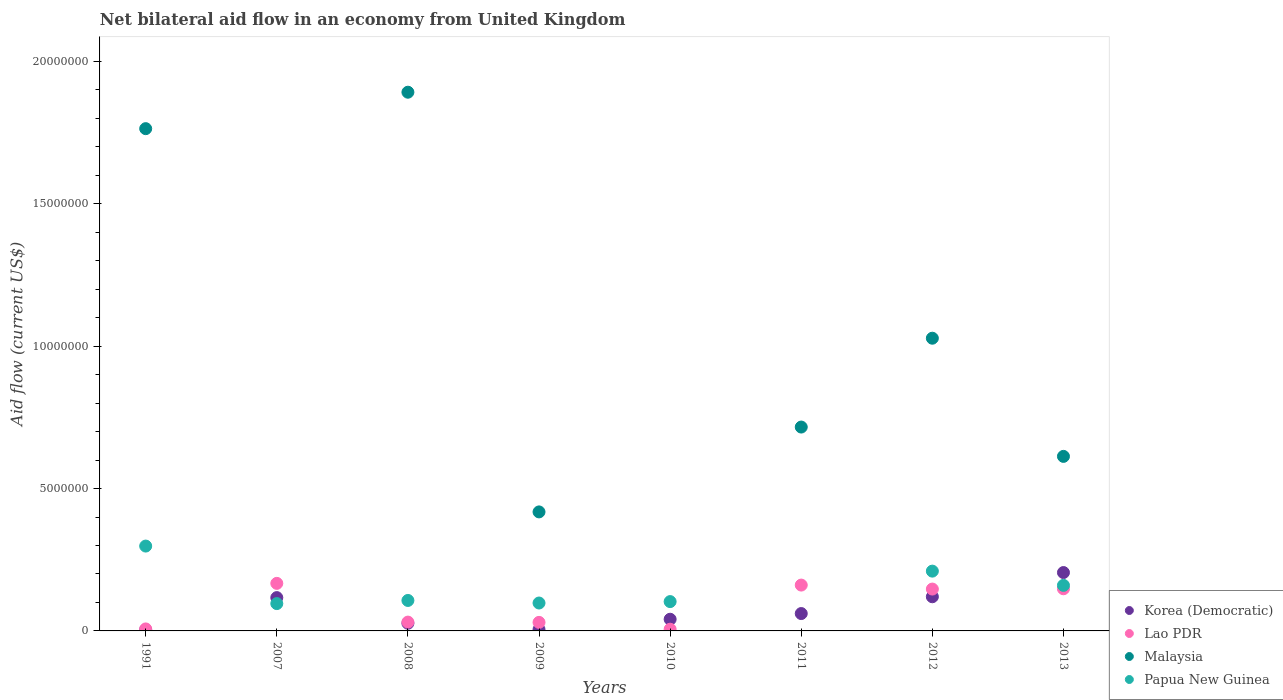How many different coloured dotlines are there?
Ensure brevity in your answer.  4. Is the number of dotlines equal to the number of legend labels?
Ensure brevity in your answer.  No. What is the net bilateral aid flow in Papua New Guinea in 2012?
Offer a terse response. 2.10e+06. Across all years, what is the maximum net bilateral aid flow in Papua New Guinea?
Offer a very short reply. 2.98e+06. Across all years, what is the minimum net bilateral aid flow in Lao PDR?
Provide a succinct answer. 6.00e+04. What is the total net bilateral aid flow in Korea (Democratic) in the graph?
Make the answer very short. 5.80e+06. What is the difference between the net bilateral aid flow in Lao PDR in 2007 and that in 2010?
Keep it short and to the point. 1.61e+06. What is the difference between the net bilateral aid flow in Papua New Guinea in 2008 and the net bilateral aid flow in Lao PDR in 2007?
Your answer should be compact. -6.00e+05. What is the average net bilateral aid flow in Malaysia per year?
Make the answer very short. 8.04e+06. What is the ratio of the net bilateral aid flow in Lao PDR in 2009 to that in 2011?
Provide a short and direct response. 0.19. Is the difference between the net bilateral aid flow in Lao PDR in 1991 and 2008 greater than the difference between the net bilateral aid flow in Korea (Democratic) in 1991 and 2008?
Your answer should be compact. No. What is the difference between the highest and the second highest net bilateral aid flow in Korea (Democratic)?
Keep it short and to the point. 8.50e+05. What is the difference between the highest and the lowest net bilateral aid flow in Papua New Guinea?
Your response must be concise. 2.98e+06. In how many years, is the net bilateral aid flow in Papua New Guinea greater than the average net bilateral aid flow in Papua New Guinea taken over all years?
Ensure brevity in your answer.  3. Does the net bilateral aid flow in Malaysia monotonically increase over the years?
Keep it short and to the point. No. Is the net bilateral aid flow in Korea (Democratic) strictly greater than the net bilateral aid flow in Papua New Guinea over the years?
Keep it short and to the point. No. What is the difference between two consecutive major ticks on the Y-axis?
Provide a short and direct response. 5.00e+06. Does the graph contain any zero values?
Provide a succinct answer. Yes. Does the graph contain grids?
Make the answer very short. No. Where does the legend appear in the graph?
Your response must be concise. Bottom right. How many legend labels are there?
Your answer should be very brief. 4. How are the legend labels stacked?
Ensure brevity in your answer.  Vertical. What is the title of the graph?
Your answer should be compact. Net bilateral aid flow in an economy from United Kingdom. What is the Aid flow (current US$) of Korea (Democratic) in 1991?
Provide a short and direct response. 4.00e+04. What is the Aid flow (current US$) of Lao PDR in 1991?
Your answer should be very brief. 7.00e+04. What is the Aid flow (current US$) in Malaysia in 1991?
Your answer should be very brief. 1.76e+07. What is the Aid flow (current US$) of Papua New Guinea in 1991?
Make the answer very short. 2.98e+06. What is the Aid flow (current US$) in Korea (Democratic) in 2007?
Make the answer very short. 1.17e+06. What is the Aid flow (current US$) in Lao PDR in 2007?
Offer a terse response. 1.67e+06. What is the Aid flow (current US$) in Malaysia in 2007?
Offer a very short reply. 0. What is the Aid flow (current US$) of Papua New Guinea in 2007?
Keep it short and to the point. 9.60e+05. What is the Aid flow (current US$) in Malaysia in 2008?
Offer a terse response. 1.89e+07. What is the Aid flow (current US$) of Papua New Guinea in 2008?
Make the answer very short. 1.07e+06. What is the Aid flow (current US$) of Lao PDR in 2009?
Keep it short and to the point. 3.00e+05. What is the Aid flow (current US$) in Malaysia in 2009?
Give a very brief answer. 4.18e+06. What is the Aid flow (current US$) in Papua New Guinea in 2009?
Keep it short and to the point. 9.80e+05. What is the Aid flow (current US$) in Korea (Democratic) in 2010?
Your answer should be very brief. 4.10e+05. What is the Aid flow (current US$) in Malaysia in 2010?
Offer a very short reply. 0. What is the Aid flow (current US$) of Papua New Guinea in 2010?
Your response must be concise. 1.03e+06. What is the Aid flow (current US$) of Korea (Democratic) in 2011?
Offer a very short reply. 6.10e+05. What is the Aid flow (current US$) of Lao PDR in 2011?
Your answer should be very brief. 1.61e+06. What is the Aid flow (current US$) in Malaysia in 2011?
Your answer should be compact. 7.16e+06. What is the Aid flow (current US$) in Korea (Democratic) in 2012?
Keep it short and to the point. 1.20e+06. What is the Aid flow (current US$) in Lao PDR in 2012?
Provide a succinct answer. 1.47e+06. What is the Aid flow (current US$) of Malaysia in 2012?
Keep it short and to the point. 1.03e+07. What is the Aid flow (current US$) of Papua New Guinea in 2012?
Make the answer very short. 2.10e+06. What is the Aid flow (current US$) in Korea (Democratic) in 2013?
Give a very brief answer. 2.05e+06. What is the Aid flow (current US$) of Lao PDR in 2013?
Make the answer very short. 1.48e+06. What is the Aid flow (current US$) of Malaysia in 2013?
Ensure brevity in your answer.  6.13e+06. What is the Aid flow (current US$) in Papua New Guinea in 2013?
Offer a very short reply. 1.60e+06. Across all years, what is the maximum Aid flow (current US$) in Korea (Democratic)?
Give a very brief answer. 2.05e+06. Across all years, what is the maximum Aid flow (current US$) of Lao PDR?
Your answer should be compact. 1.67e+06. Across all years, what is the maximum Aid flow (current US$) of Malaysia?
Your answer should be compact. 1.89e+07. Across all years, what is the maximum Aid flow (current US$) of Papua New Guinea?
Your answer should be compact. 2.98e+06. Across all years, what is the minimum Aid flow (current US$) in Korea (Democratic)?
Provide a succinct answer. 4.00e+04. Across all years, what is the minimum Aid flow (current US$) of Lao PDR?
Offer a terse response. 6.00e+04. Across all years, what is the minimum Aid flow (current US$) in Papua New Guinea?
Provide a succinct answer. 0. What is the total Aid flow (current US$) in Korea (Democratic) in the graph?
Offer a very short reply. 5.80e+06. What is the total Aid flow (current US$) of Lao PDR in the graph?
Offer a terse response. 6.97e+06. What is the total Aid flow (current US$) of Malaysia in the graph?
Offer a very short reply. 6.43e+07. What is the total Aid flow (current US$) of Papua New Guinea in the graph?
Your answer should be very brief. 1.07e+07. What is the difference between the Aid flow (current US$) in Korea (Democratic) in 1991 and that in 2007?
Provide a succinct answer. -1.13e+06. What is the difference between the Aid flow (current US$) in Lao PDR in 1991 and that in 2007?
Your answer should be compact. -1.60e+06. What is the difference between the Aid flow (current US$) in Papua New Guinea in 1991 and that in 2007?
Give a very brief answer. 2.02e+06. What is the difference between the Aid flow (current US$) in Malaysia in 1991 and that in 2008?
Your response must be concise. -1.28e+06. What is the difference between the Aid flow (current US$) in Papua New Guinea in 1991 and that in 2008?
Make the answer very short. 1.91e+06. What is the difference between the Aid flow (current US$) in Malaysia in 1991 and that in 2009?
Offer a very short reply. 1.35e+07. What is the difference between the Aid flow (current US$) in Korea (Democratic) in 1991 and that in 2010?
Offer a terse response. -3.70e+05. What is the difference between the Aid flow (current US$) in Lao PDR in 1991 and that in 2010?
Keep it short and to the point. 10000. What is the difference between the Aid flow (current US$) in Papua New Guinea in 1991 and that in 2010?
Your answer should be very brief. 1.95e+06. What is the difference between the Aid flow (current US$) in Korea (Democratic) in 1991 and that in 2011?
Provide a succinct answer. -5.70e+05. What is the difference between the Aid flow (current US$) of Lao PDR in 1991 and that in 2011?
Ensure brevity in your answer.  -1.54e+06. What is the difference between the Aid flow (current US$) in Malaysia in 1991 and that in 2011?
Keep it short and to the point. 1.05e+07. What is the difference between the Aid flow (current US$) of Korea (Democratic) in 1991 and that in 2012?
Make the answer very short. -1.16e+06. What is the difference between the Aid flow (current US$) in Lao PDR in 1991 and that in 2012?
Ensure brevity in your answer.  -1.40e+06. What is the difference between the Aid flow (current US$) in Malaysia in 1991 and that in 2012?
Make the answer very short. 7.36e+06. What is the difference between the Aid flow (current US$) of Papua New Guinea in 1991 and that in 2012?
Ensure brevity in your answer.  8.80e+05. What is the difference between the Aid flow (current US$) in Korea (Democratic) in 1991 and that in 2013?
Offer a terse response. -2.01e+06. What is the difference between the Aid flow (current US$) of Lao PDR in 1991 and that in 2013?
Ensure brevity in your answer.  -1.41e+06. What is the difference between the Aid flow (current US$) in Malaysia in 1991 and that in 2013?
Offer a very short reply. 1.15e+07. What is the difference between the Aid flow (current US$) in Papua New Guinea in 1991 and that in 2013?
Provide a succinct answer. 1.38e+06. What is the difference between the Aid flow (current US$) of Lao PDR in 2007 and that in 2008?
Provide a succinct answer. 1.36e+06. What is the difference between the Aid flow (current US$) of Papua New Guinea in 2007 and that in 2008?
Give a very brief answer. -1.10e+05. What is the difference between the Aid flow (current US$) of Korea (Democratic) in 2007 and that in 2009?
Provide a succinct answer. 1.12e+06. What is the difference between the Aid flow (current US$) in Lao PDR in 2007 and that in 2009?
Give a very brief answer. 1.37e+06. What is the difference between the Aid flow (current US$) of Korea (Democratic) in 2007 and that in 2010?
Give a very brief answer. 7.60e+05. What is the difference between the Aid flow (current US$) of Lao PDR in 2007 and that in 2010?
Your answer should be compact. 1.61e+06. What is the difference between the Aid flow (current US$) in Korea (Democratic) in 2007 and that in 2011?
Offer a terse response. 5.60e+05. What is the difference between the Aid flow (current US$) of Lao PDR in 2007 and that in 2011?
Offer a terse response. 6.00e+04. What is the difference between the Aid flow (current US$) of Papua New Guinea in 2007 and that in 2012?
Provide a succinct answer. -1.14e+06. What is the difference between the Aid flow (current US$) of Korea (Democratic) in 2007 and that in 2013?
Keep it short and to the point. -8.80e+05. What is the difference between the Aid flow (current US$) of Lao PDR in 2007 and that in 2013?
Ensure brevity in your answer.  1.90e+05. What is the difference between the Aid flow (current US$) in Papua New Guinea in 2007 and that in 2013?
Keep it short and to the point. -6.40e+05. What is the difference between the Aid flow (current US$) in Korea (Democratic) in 2008 and that in 2009?
Your answer should be compact. 2.20e+05. What is the difference between the Aid flow (current US$) in Malaysia in 2008 and that in 2009?
Give a very brief answer. 1.47e+07. What is the difference between the Aid flow (current US$) in Korea (Democratic) in 2008 and that in 2010?
Keep it short and to the point. -1.40e+05. What is the difference between the Aid flow (current US$) of Lao PDR in 2008 and that in 2010?
Provide a short and direct response. 2.50e+05. What is the difference between the Aid flow (current US$) of Lao PDR in 2008 and that in 2011?
Provide a succinct answer. -1.30e+06. What is the difference between the Aid flow (current US$) of Malaysia in 2008 and that in 2011?
Offer a very short reply. 1.18e+07. What is the difference between the Aid flow (current US$) in Korea (Democratic) in 2008 and that in 2012?
Offer a very short reply. -9.30e+05. What is the difference between the Aid flow (current US$) of Lao PDR in 2008 and that in 2012?
Provide a succinct answer. -1.16e+06. What is the difference between the Aid flow (current US$) of Malaysia in 2008 and that in 2012?
Your response must be concise. 8.64e+06. What is the difference between the Aid flow (current US$) of Papua New Guinea in 2008 and that in 2012?
Your answer should be compact. -1.03e+06. What is the difference between the Aid flow (current US$) in Korea (Democratic) in 2008 and that in 2013?
Provide a short and direct response. -1.78e+06. What is the difference between the Aid flow (current US$) in Lao PDR in 2008 and that in 2013?
Provide a short and direct response. -1.17e+06. What is the difference between the Aid flow (current US$) in Malaysia in 2008 and that in 2013?
Ensure brevity in your answer.  1.28e+07. What is the difference between the Aid flow (current US$) of Papua New Guinea in 2008 and that in 2013?
Give a very brief answer. -5.30e+05. What is the difference between the Aid flow (current US$) of Korea (Democratic) in 2009 and that in 2010?
Your response must be concise. -3.60e+05. What is the difference between the Aid flow (current US$) in Korea (Democratic) in 2009 and that in 2011?
Offer a very short reply. -5.60e+05. What is the difference between the Aid flow (current US$) in Lao PDR in 2009 and that in 2011?
Provide a succinct answer. -1.31e+06. What is the difference between the Aid flow (current US$) of Malaysia in 2009 and that in 2011?
Your response must be concise. -2.98e+06. What is the difference between the Aid flow (current US$) of Korea (Democratic) in 2009 and that in 2012?
Your answer should be very brief. -1.15e+06. What is the difference between the Aid flow (current US$) in Lao PDR in 2009 and that in 2012?
Keep it short and to the point. -1.17e+06. What is the difference between the Aid flow (current US$) in Malaysia in 2009 and that in 2012?
Provide a short and direct response. -6.10e+06. What is the difference between the Aid flow (current US$) in Papua New Guinea in 2009 and that in 2012?
Offer a very short reply. -1.12e+06. What is the difference between the Aid flow (current US$) in Korea (Democratic) in 2009 and that in 2013?
Offer a terse response. -2.00e+06. What is the difference between the Aid flow (current US$) in Lao PDR in 2009 and that in 2013?
Ensure brevity in your answer.  -1.18e+06. What is the difference between the Aid flow (current US$) of Malaysia in 2009 and that in 2013?
Make the answer very short. -1.95e+06. What is the difference between the Aid flow (current US$) in Papua New Guinea in 2009 and that in 2013?
Make the answer very short. -6.20e+05. What is the difference between the Aid flow (current US$) of Korea (Democratic) in 2010 and that in 2011?
Provide a short and direct response. -2.00e+05. What is the difference between the Aid flow (current US$) in Lao PDR in 2010 and that in 2011?
Provide a short and direct response. -1.55e+06. What is the difference between the Aid flow (current US$) of Korea (Democratic) in 2010 and that in 2012?
Make the answer very short. -7.90e+05. What is the difference between the Aid flow (current US$) in Lao PDR in 2010 and that in 2012?
Keep it short and to the point. -1.41e+06. What is the difference between the Aid flow (current US$) in Papua New Guinea in 2010 and that in 2012?
Give a very brief answer. -1.07e+06. What is the difference between the Aid flow (current US$) in Korea (Democratic) in 2010 and that in 2013?
Ensure brevity in your answer.  -1.64e+06. What is the difference between the Aid flow (current US$) of Lao PDR in 2010 and that in 2013?
Keep it short and to the point. -1.42e+06. What is the difference between the Aid flow (current US$) in Papua New Guinea in 2010 and that in 2013?
Keep it short and to the point. -5.70e+05. What is the difference between the Aid flow (current US$) of Korea (Democratic) in 2011 and that in 2012?
Your answer should be very brief. -5.90e+05. What is the difference between the Aid flow (current US$) of Malaysia in 2011 and that in 2012?
Provide a succinct answer. -3.12e+06. What is the difference between the Aid flow (current US$) in Korea (Democratic) in 2011 and that in 2013?
Your response must be concise. -1.44e+06. What is the difference between the Aid flow (current US$) of Malaysia in 2011 and that in 2013?
Ensure brevity in your answer.  1.03e+06. What is the difference between the Aid flow (current US$) of Korea (Democratic) in 2012 and that in 2013?
Your answer should be compact. -8.50e+05. What is the difference between the Aid flow (current US$) in Lao PDR in 2012 and that in 2013?
Make the answer very short. -10000. What is the difference between the Aid flow (current US$) in Malaysia in 2012 and that in 2013?
Offer a terse response. 4.15e+06. What is the difference between the Aid flow (current US$) of Korea (Democratic) in 1991 and the Aid flow (current US$) of Lao PDR in 2007?
Offer a very short reply. -1.63e+06. What is the difference between the Aid flow (current US$) in Korea (Democratic) in 1991 and the Aid flow (current US$) in Papua New Guinea in 2007?
Your answer should be very brief. -9.20e+05. What is the difference between the Aid flow (current US$) in Lao PDR in 1991 and the Aid flow (current US$) in Papua New Guinea in 2007?
Provide a succinct answer. -8.90e+05. What is the difference between the Aid flow (current US$) in Malaysia in 1991 and the Aid flow (current US$) in Papua New Guinea in 2007?
Make the answer very short. 1.67e+07. What is the difference between the Aid flow (current US$) of Korea (Democratic) in 1991 and the Aid flow (current US$) of Malaysia in 2008?
Ensure brevity in your answer.  -1.89e+07. What is the difference between the Aid flow (current US$) in Korea (Democratic) in 1991 and the Aid flow (current US$) in Papua New Guinea in 2008?
Offer a very short reply. -1.03e+06. What is the difference between the Aid flow (current US$) of Lao PDR in 1991 and the Aid flow (current US$) of Malaysia in 2008?
Provide a short and direct response. -1.88e+07. What is the difference between the Aid flow (current US$) in Lao PDR in 1991 and the Aid flow (current US$) in Papua New Guinea in 2008?
Your answer should be very brief. -1.00e+06. What is the difference between the Aid flow (current US$) in Malaysia in 1991 and the Aid flow (current US$) in Papua New Guinea in 2008?
Your answer should be very brief. 1.66e+07. What is the difference between the Aid flow (current US$) in Korea (Democratic) in 1991 and the Aid flow (current US$) in Lao PDR in 2009?
Ensure brevity in your answer.  -2.60e+05. What is the difference between the Aid flow (current US$) in Korea (Democratic) in 1991 and the Aid flow (current US$) in Malaysia in 2009?
Your answer should be very brief. -4.14e+06. What is the difference between the Aid flow (current US$) in Korea (Democratic) in 1991 and the Aid flow (current US$) in Papua New Guinea in 2009?
Provide a short and direct response. -9.40e+05. What is the difference between the Aid flow (current US$) in Lao PDR in 1991 and the Aid flow (current US$) in Malaysia in 2009?
Make the answer very short. -4.11e+06. What is the difference between the Aid flow (current US$) of Lao PDR in 1991 and the Aid flow (current US$) of Papua New Guinea in 2009?
Your answer should be very brief. -9.10e+05. What is the difference between the Aid flow (current US$) in Malaysia in 1991 and the Aid flow (current US$) in Papua New Guinea in 2009?
Ensure brevity in your answer.  1.67e+07. What is the difference between the Aid flow (current US$) of Korea (Democratic) in 1991 and the Aid flow (current US$) of Papua New Guinea in 2010?
Provide a short and direct response. -9.90e+05. What is the difference between the Aid flow (current US$) in Lao PDR in 1991 and the Aid flow (current US$) in Papua New Guinea in 2010?
Ensure brevity in your answer.  -9.60e+05. What is the difference between the Aid flow (current US$) of Malaysia in 1991 and the Aid flow (current US$) of Papua New Guinea in 2010?
Provide a succinct answer. 1.66e+07. What is the difference between the Aid flow (current US$) of Korea (Democratic) in 1991 and the Aid flow (current US$) of Lao PDR in 2011?
Offer a terse response. -1.57e+06. What is the difference between the Aid flow (current US$) in Korea (Democratic) in 1991 and the Aid flow (current US$) in Malaysia in 2011?
Offer a very short reply. -7.12e+06. What is the difference between the Aid flow (current US$) in Lao PDR in 1991 and the Aid flow (current US$) in Malaysia in 2011?
Provide a short and direct response. -7.09e+06. What is the difference between the Aid flow (current US$) of Korea (Democratic) in 1991 and the Aid flow (current US$) of Lao PDR in 2012?
Provide a short and direct response. -1.43e+06. What is the difference between the Aid flow (current US$) of Korea (Democratic) in 1991 and the Aid flow (current US$) of Malaysia in 2012?
Provide a succinct answer. -1.02e+07. What is the difference between the Aid flow (current US$) in Korea (Democratic) in 1991 and the Aid flow (current US$) in Papua New Guinea in 2012?
Ensure brevity in your answer.  -2.06e+06. What is the difference between the Aid flow (current US$) in Lao PDR in 1991 and the Aid flow (current US$) in Malaysia in 2012?
Your answer should be very brief. -1.02e+07. What is the difference between the Aid flow (current US$) of Lao PDR in 1991 and the Aid flow (current US$) of Papua New Guinea in 2012?
Provide a succinct answer. -2.03e+06. What is the difference between the Aid flow (current US$) in Malaysia in 1991 and the Aid flow (current US$) in Papua New Guinea in 2012?
Your answer should be very brief. 1.55e+07. What is the difference between the Aid flow (current US$) of Korea (Democratic) in 1991 and the Aid flow (current US$) of Lao PDR in 2013?
Provide a short and direct response. -1.44e+06. What is the difference between the Aid flow (current US$) in Korea (Democratic) in 1991 and the Aid flow (current US$) in Malaysia in 2013?
Give a very brief answer. -6.09e+06. What is the difference between the Aid flow (current US$) of Korea (Democratic) in 1991 and the Aid flow (current US$) of Papua New Guinea in 2013?
Provide a short and direct response. -1.56e+06. What is the difference between the Aid flow (current US$) of Lao PDR in 1991 and the Aid flow (current US$) of Malaysia in 2013?
Keep it short and to the point. -6.06e+06. What is the difference between the Aid flow (current US$) of Lao PDR in 1991 and the Aid flow (current US$) of Papua New Guinea in 2013?
Give a very brief answer. -1.53e+06. What is the difference between the Aid flow (current US$) of Malaysia in 1991 and the Aid flow (current US$) of Papua New Guinea in 2013?
Offer a terse response. 1.60e+07. What is the difference between the Aid flow (current US$) in Korea (Democratic) in 2007 and the Aid flow (current US$) in Lao PDR in 2008?
Give a very brief answer. 8.60e+05. What is the difference between the Aid flow (current US$) of Korea (Democratic) in 2007 and the Aid flow (current US$) of Malaysia in 2008?
Provide a succinct answer. -1.78e+07. What is the difference between the Aid flow (current US$) of Korea (Democratic) in 2007 and the Aid flow (current US$) of Papua New Guinea in 2008?
Provide a short and direct response. 1.00e+05. What is the difference between the Aid flow (current US$) of Lao PDR in 2007 and the Aid flow (current US$) of Malaysia in 2008?
Ensure brevity in your answer.  -1.72e+07. What is the difference between the Aid flow (current US$) in Lao PDR in 2007 and the Aid flow (current US$) in Papua New Guinea in 2008?
Your response must be concise. 6.00e+05. What is the difference between the Aid flow (current US$) of Korea (Democratic) in 2007 and the Aid flow (current US$) of Lao PDR in 2009?
Offer a very short reply. 8.70e+05. What is the difference between the Aid flow (current US$) of Korea (Democratic) in 2007 and the Aid flow (current US$) of Malaysia in 2009?
Provide a short and direct response. -3.01e+06. What is the difference between the Aid flow (current US$) in Korea (Democratic) in 2007 and the Aid flow (current US$) in Papua New Guinea in 2009?
Provide a succinct answer. 1.90e+05. What is the difference between the Aid flow (current US$) in Lao PDR in 2007 and the Aid flow (current US$) in Malaysia in 2009?
Your answer should be compact. -2.51e+06. What is the difference between the Aid flow (current US$) in Lao PDR in 2007 and the Aid flow (current US$) in Papua New Guinea in 2009?
Offer a very short reply. 6.90e+05. What is the difference between the Aid flow (current US$) in Korea (Democratic) in 2007 and the Aid flow (current US$) in Lao PDR in 2010?
Offer a terse response. 1.11e+06. What is the difference between the Aid flow (current US$) of Lao PDR in 2007 and the Aid flow (current US$) of Papua New Guinea in 2010?
Make the answer very short. 6.40e+05. What is the difference between the Aid flow (current US$) of Korea (Democratic) in 2007 and the Aid flow (current US$) of Lao PDR in 2011?
Your answer should be very brief. -4.40e+05. What is the difference between the Aid flow (current US$) of Korea (Democratic) in 2007 and the Aid flow (current US$) of Malaysia in 2011?
Provide a short and direct response. -5.99e+06. What is the difference between the Aid flow (current US$) in Lao PDR in 2007 and the Aid flow (current US$) in Malaysia in 2011?
Your answer should be compact. -5.49e+06. What is the difference between the Aid flow (current US$) in Korea (Democratic) in 2007 and the Aid flow (current US$) in Lao PDR in 2012?
Your answer should be very brief. -3.00e+05. What is the difference between the Aid flow (current US$) of Korea (Democratic) in 2007 and the Aid flow (current US$) of Malaysia in 2012?
Make the answer very short. -9.11e+06. What is the difference between the Aid flow (current US$) of Korea (Democratic) in 2007 and the Aid flow (current US$) of Papua New Guinea in 2012?
Ensure brevity in your answer.  -9.30e+05. What is the difference between the Aid flow (current US$) of Lao PDR in 2007 and the Aid flow (current US$) of Malaysia in 2012?
Your response must be concise. -8.61e+06. What is the difference between the Aid flow (current US$) of Lao PDR in 2007 and the Aid flow (current US$) of Papua New Guinea in 2012?
Offer a very short reply. -4.30e+05. What is the difference between the Aid flow (current US$) of Korea (Democratic) in 2007 and the Aid flow (current US$) of Lao PDR in 2013?
Keep it short and to the point. -3.10e+05. What is the difference between the Aid flow (current US$) in Korea (Democratic) in 2007 and the Aid flow (current US$) in Malaysia in 2013?
Ensure brevity in your answer.  -4.96e+06. What is the difference between the Aid flow (current US$) of Korea (Democratic) in 2007 and the Aid flow (current US$) of Papua New Guinea in 2013?
Keep it short and to the point. -4.30e+05. What is the difference between the Aid flow (current US$) in Lao PDR in 2007 and the Aid flow (current US$) in Malaysia in 2013?
Make the answer very short. -4.46e+06. What is the difference between the Aid flow (current US$) in Lao PDR in 2007 and the Aid flow (current US$) in Papua New Guinea in 2013?
Your response must be concise. 7.00e+04. What is the difference between the Aid flow (current US$) in Korea (Democratic) in 2008 and the Aid flow (current US$) in Malaysia in 2009?
Offer a terse response. -3.91e+06. What is the difference between the Aid flow (current US$) in Korea (Democratic) in 2008 and the Aid flow (current US$) in Papua New Guinea in 2009?
Give a very brief answer. -7.10e+05. What is the difference between the Aid flow (current US$) in Lao PDR in 2008 and the Aid flow (current US$) in Malaysia in 2009?
Offer a very short reply. -3.87e+06. What is the difference between the Aid flow (current US$) of Lao PDR in 2008 and the Aid flow (current US$) of Papua New Guinea in 2009?
Ensure brevity in your answer.  -6.70e+05. What is the difference between the Aid flow (current US$) in Malaysia in 2008 and the Aid flow (current US$) in Papua New Guinea in 2009?
Give a very brief answer. 1.79e+07. What is the difference between the Aid flow (current US$) of Korea (Democratic) in 2008 and the Aid flow (current US$) of Lao PDR in 2010?
Make the answer very short. 2.10e+05. What is the difference between the Aid flow (current US$) in Korea (Democratic) in 2008 and the Aid flow (current US$) in Papua New Guinea in 2010?
Your answer should be compact. -7.60e+05. What is the difference between the Aid flow (current US$) of Lao PDR in 2008 and the Aid flow (current US$) of Papua New Guinea in 2010?
Keep it short and to the point. -7.20e+05. What is the difference between the Aid flow (current US$) of Malaysia in 2008 and the Aid flow (current US$) of Papua New Guinea in 2010?
Give a very brief answer. 1.79e+07. What is the difference between the Aid flow (current US$) of Korea (Democratic) in 2008 and the Aid flow (current US$) of Lao PDR in 2011?
Offer a terse response. -1.34e+06. What is the difference between the Aid flow (current US$) in Korea (Democratic) in 2008 and the Aid flow (current US$) in Malaysia in 2011?
Make the answer very short. -6.89e+06. What is the difference between the Aid flow (current US$) in Lao PDR in 2008 and the Aid flow (current US$) in Malaysia in 2011?
Your answer should be very brief. -6.85e+06. What is the difference between the Aid flow (current US$) in Korea (Democratic) in 2008 and the Aid flow (current US$) in Lao PDR in 2012?
Offer a very short reply. -1.20e+06. What is the difference between the Aid flow (current US$) in Korea (Democratic) in 2008 and the Aid flow (current US$) in Malaysia in 2012?
Give a very brief answer. -1.00e+07. What is the difference between the Aid flow (current US$) of Korea (Democratic) in 2008 and the Aid flow (current US$) of Papua New Guinea in 2012?
Offer a very short reply. -1.83e+06. What is the difference between the Aid flow (current US$) in Lao PDR in 2008 and the Aid flow (current US$) in Malaysia in 2012?
Your response must be concise. -9.97e+06. What is the difference between the Aid flow (current US$) in Lao PDR in 2008 and the Aid flow (current US$) in Papua New Guinea in 2012?
Your answer should be compact. -1.79e+06. What is the difference between the Aid flow (current US$) in Malaysia in 2008 and the Aid flow (current US$) in Papua New Guinea in 2012?
Provide a short and direct response. 1.68e+07. What is the difference between the Aid flow (current US$) of Korea (Democratic) in 2008 and the Aid flow (current US$) of Lao PDR in 2013?
Your answer should be compact. -1.21e+06. What is the difference between the Aid flow (current US$) of Korea (Democratic) in 2008 and the Aid flow (current US$) of Malaysia in 2013?
Keep it short and to the point. -5.86e+06. What is the difference between the Aid flow (current US$) in Korea (Democratic) in 2008 and the Aid flow (current US$) in Papua New Guinea in 2013?
Ensure brevity in your answer.  -1.33e+06. What is the difference between the Aid flow (current US$) of Lao PDR in 2008 and the Aid flow (current US$) of Malaysia in 2013?
Provide a short and direct response. -5.82e+06. What is the difference between the Aid flow (current US$) of Lao PDR in 2008 and the Aid flow (current US$) of Papua New Guinea in 2013?
Keep it short and to the point. -1.29e+06. What is the difference between the Aid flow (current US$) in Malaysia in 2008 and the Aid flow (current US$) in Papua New Guinea in 2013?
Your answer should be very brief. 1.73e+07. What is the difference between the Aid flow (current US$) in Korea (Democratic) in 2009 and the Aid flow (current US$) in Papua New Guinea in 2010?
Your answer should be very brief. -9.80e+05. What is the difference between the Aid flow (current US$) of Lao PDR in 2009 and the Aid flow (current US$) of Papua New Guinea in 2010?
Keep it short and to the point. -7.30e+05. What is the difference between the Aid flow (current US$) in Malaysia in 2009 and the Aid flow (current US$) in Papua New Guinea in 2010?
Your response must be concise. 3.15e+06. What is the difference between the Aid flow (current US$) of Korea (Democratic) in 2009 and the Aid flow (current US$) of Lao PDR in 2011?
Make the answer very short. -1.56e+06. What is the difference between the Aid flow (current US$) in Korea (Democratic) in 2009 and the Aid flow (current US$) in Malaysia in 2011?
Keep it short and to the point. -7.11e+06. What is the difference between the Aid flow (current US$) in Lao PDR in 2009 and the Aid flow (current US$) in Malaysia in 2011?
Ensure brevity in your answer.  -6.86e+06. What is the difference between the Aid flow (current US$) in Korea (Democratic) in 2009 and the Aid flow (current US$) in Lao PDR in 2012?
Offer a terse response. -1.42e+06. What is the difference between the Aid flow (current US$) of Korea (Democratic) in 2009 and the Aid flow (current US$) of Malaysia in 2012?
Provide a short and direct response. -1.02e+07. What is the difference between the Aid flow (current US$) in Korea (Democratic) in 2009 and the Aid flow (current US$) in Papua New Guinea in 2012?
Your answer should be very brief. -2.05e+06. What is the difference between the Aid flow (current US$) of Lao PDR in 2009 and the Aid flow (current US$) of Malaysia in 2012?
Offer a very short reply. -9.98e+06. What is the difference between the Aid flow (current US$) of Lao PDR in 2009 and the Aid flow (current US$) of Papua New Guinea in 2012?
Ensure brevity in your answer.  -1.80e+06. What is the difference between the Aid flow (current US$) in Malaysia in 2009 and the Aid flow (current US$) in Papua New Guinea in 2012?
Ensure brevity in your answer.  2.08e+06. What is the difference between the Aid flow (current US$) of Korea (Democratic) in 2009 and the Aid flow (current US$) of Lao PDR in 2013?
Ensure brevity in your answer.  -1.43e+06. What is the difference between the Aid flow (current US$) of Korea (Democratic) in 2009 and the Aid flow (current US$) of Malaysia in 2013?
Offer a terse response. -6.08e+06. What is the difference between the Aid flow (current US$) in Korea (Democratic) in 2009 and the Aid flow (current US$) in Papua New Guinea in 2013?
Provide a short and direct response. -1.55e+06. What is the difference between the Aid flow (current US$) in Lao PDR in 2009 and the Aid flow (current US$) in Malaysia in 2013?
Your answer should be compact. -5.83e+06. What is the difference between the Aid flow (current US$) in Lao PDR in 2009 and the Aid flow (current US$) in Papua New Guinea in 2013?
Your response must be concise. -1.30e+06. What is the difference between the Aid flow (current US$) in Malaysia in 2009 and the Aid flow (current US$) in Papua New Guinea in 2013?
Provide a succinct answer. 2.58e+06. What is the difference between the Aid flow (current US$) in Korea (Democratic) in 2010 and the Aid flow (current US$) in Lao PDR in 2011?
Give a very brief answer. -1.20e+06. What is the difference between the Aid flow (current US$) of Korea (Democratic) in 2010 and the Aid flow (current US$) of Malaysia in 2011?
Keep it short and to the point. -6.75e+06. What is the difference between the Aid flow (current US$) in Lao PDR in 2010 and the Aid flow (current US$) in Malaysia in 2011?
Provide a short and direct response. -7.10e+06. What is the difference between the Aid flow (current US$) in Korea (Democratic) in 2010 and the Aid flow (current US$) in Lao PDR in 2012?
Your response must be concise. -1.06e+06. What is the difference between the Aid flow (current US$) in Korea (Democratic) in 2010 and the Aid flow (current US$) in Malaysia in 2012?
Ensure brevity in your answer.  -9.87e+06. What is the difference between the Aid flow (current US$) in Korea (Democratic) in 2010 and the Aid flow (current US$) in Papua New Guinea in 2012?
Offer a very short reply. -1.69e+06. What is the difference between the Aid flow (current US$) in Lao PDR in 2010 and the Aid flow (current US$) in Malaysia in 2012?
Provide a short and direct response. -1.02e+07. What is the difference between the Aid flow (current US$) of Lao PDR in 2010 and the Aid flow (current US$) of Papua New Guinea in 2012?
Give a very brief answer. -2.04e+06. What is the difference between the Aid flow (current US$) of Korea (Democratic) in 2010 and the Aid flow (current US$) of Lao PDR in 2013?
Offer a terse response. -1.07e+06. What is the difference between the Aid flow (current US$) in Korea (Democratic) in 2010 and the Aid flow (current US$) in Malaysia in 2013?
Provide a short and direct response. -5.72e+06. What is the difference between the Aid flow (current US$) in Korea (Democratic) in 2010 and the Aid flow (current US$) in Papua New Guinea in 2013?
Offer a very short reply. -1.19e+06. What is the difference between the Aid flow (current US$) of Lao PDR in 2010 and the Aid flow (current US$) of Malaysia in 2013?
Offer a very short reply. -6.07e+06. What is the difference between the Aid flow (current US$) of Lao PDR in 2010 and the Aid flow (current US$) of Papua New Guinea in 2013?
Keep it short and to the point. -1.54e+06. What is the difference between the Aid flow (current US$) of Korea (Democratic) in 2011 and the Aid flow (current US$) of Lao PDR in 2012?
Provide a short and direct response. -8.60e+05. What is the difference between the Aid flow (current US$) of Korea (Democratic) in 2011 and the Aid flow (current US$) of Malaysia in 2012?
Your response must be concise. -9.67e+06. What is the difference between the Aid flow (current US$) of Korea (Democratic) in 2011 and the Aid flow (current US$) of Papua New Guinea in 2012?
Your answer should be very brief. -1.49e+06. What is the difference between the Aid flow (current US$) in Lao PDR in 2011 and the Aid flow (current US$) in Malaysia in 2012?
Keep it short and to the point. -8.67e+06. What is the difference between the Aid flow (current US$) of Lao PDR in 2011 and the Aid flow (current US$) of Papua New Guinea in 2012?
Give a very brief answer. -4.90e+05. What is the difference between the Aid flow (current US$) in Malaysia in 2011 and the Aid flow (current US$) in Papua New Guinea in 2012?
Provide a short and direct response. 5.06e+06. What is the difference between the Aid flow (current US$) in Korea (Democratic) in 2011 and the Aid flow (current US$) in Lao PDR in 2013?
Give a very brief answer. -8.70e+05. What is the difference between the Aid flow (current US$) of Korea (Democratic) in 2011 and the Aid flow (current US$) of Malaysia in 2013?
Ensure brevity in your answer.  -5.52e+06. What is the difference between the Aid flow (current US$) in Korea (Democratic) in 2011 and the Aid flow (current US$) in Papua New Guinea in 2013?
Your answer should be very brief. -9.90e+05. What is the difference between the Aid flow (current US$) of Lao PDR in 2011 and the Aid flow (current US$) of Malaysia in 2013?
Provide a short and direct response. -4.52e+06. What is the difference between the Aid flow (current US$) in Lao PDR in 2011 and the Aid flow (current US$) in Papua New Guinea in 2013?
Your answer should be very brief. 10000. What is the difference between the Aid flow (current US$) in Malaysia in 2011 and the Aid flow (current US$) in Papua New Guinea in 2013?
Your answer should be very brief. 5.56e+06. What is the difference between the Aid flow (current US$) in Korea (Democratic) in 2012 and the Aid flow (current US$) in Lao PDR in 2013?
Your response must be concise. -2.80e+05. What is the difference between the Aid flow (current US$) in Korea (Democratic) in 2012 and the Aid flow (current US$) in Malaysia in 2013?
Ensure brevity in your answer.  -4.93e+06. What is the difference between the Aid flow (current US$) of Korea (Democratic) in 2012 and the Aid flow (current US$) of Papua New Guinea in 2013?
Your response must be concise. -4.00e+05. What is the difference between the Aid flow (current US$) in Lao PDR in 2012 and the Aid flow (current US$) in Malaysia in 2013?
Provide a short and direct response. -4.66e+06. What is the difference between the Aid flow (current US$) of Malaysia in 2012 and the Aid flow (current US$) of Papua New Guinea in 2013?
Offer a very short reply. 8.68e+06. What is the average Aid flow (current US$) in Korea (Democratic) per year?
Provide a short and direct response. 7.25e+05. What is the average Aid flow (current US$) in Lao PDR per year?
Provide a succinct answer. 8.71e+05. What is the average Aid flow (current US$) in Malaysia per year?
Keep it short and to the point. 8.04e+06. What is the average Aid flow (current US$) in Papua New Guinea per year?
Your response must be concise. 1.34e+06. In the year 1991, what is the difference between the Aid flow (current US$) of Korea (Democratic) and Aid flow (current US$) of Malaysia?
Your answer should be very brief. -1.76e+07. In the year 1991, what is the difference between the Aid flow (current US$) in Korea (Democratic) and Aid flow (current US$) in Papua New Guinea?
Your response must be concise. -2.94e+06. In the year 1991, what is the difference between the Aid flow (current US$) of Lao PDR and Aid flow (current US$) of Malaysia?
Keep it short and to the point. -1.76e+07. In the year 1991, what is the difference between the Aid flow (current US$) in Lao PDR and Aid flow (current US$) in Papua New Guinea?
Provide a short and direct response. -2.91e+06. In the year 1991, what is the difference between the Aid flow (current US$) of Malaysia and Aid flow (current US$) of Papua New Guinea?
Provide a succinct answer. 1.47e+07. In the year 2007, what is the difference between the Aid flow (current US$) in Korea (Democratic) and Aid flow (current US$) in Lao PDR?
Provide a short and direct response. -5.00e+05. In the year 2007, what is the difference between the Aid flow (current US$) in Korea (Democratic) and Aid flow (current US$) in Papua New Guinea?
Ensure brevity in your answer.  2.10e+05. In the year 2007, what is the difference between the Aid flow (current US$) of Lao PDR and Aid flow (current US$) of Papua New Guinea?
Your response must be concise. 7.10e+05. In the year 2008, what is the difference between the Aid flow (current US$) of Korea (Democratic) and Aid flow (current US$) of Malaysia?
Ensure brevity in your answer.  -1.86e+07. In the year 2008, what is the difference between the Aid flow (current US$) of Korea (Democratic) and Aid flow (current US$) of Papua New Guinea?
Ensure brevity in your answer.  -8.00e+05. In the year 2008, what is the difference between the Aid flow (current US$) in Lao PDR and Aid flow (current US$) in Malaysia?
Offer a terse response. -1.86e+07. In the year 2008, what is the difference between the Aid flow (current US$) in Lao PDR and Aid flow (current US$) in Papua New Guinea?
Offer a very short reply. -7.60e+05. In the year 2008, what is the difference between the Aid flow (current US$) in Malaysia and Aid flow (current US$) in Papua New Guinea?
Your answer should be compact. 1.78e+07. In the year 2009, what is the difference between the Aid flow (current US$) in Korea (Democratic) and Aid flow (current US$) in Malaysia?
Your answer should be very brief. -4.13e+06. In the year 2009, what is the difference between the Aid flow (current US$) in Korea (Democratic) and Aid flow (current US$) in Papua New Guinea?
Give a very brief answer. -9.30e+05. In the year 2009, what is the difference between the Aid flow (current US$) of Lao PDR and Aid flow (current US$) of Malaysia?
Offer a very short reply. -3.88e+06. In the year 2009, what is the difference between the Aid flow (current US$) of Lao PDR and Aid flow (current US$) of Papua New Guinea?
Offer a very short reply. -6.80e+05. In the year 2009, what is the difference between the Aid flow (current US$) of Malaysia and Aid flow (current US$) of Papua New Guinea?
Provide a short and direct response. 3.20e+06. In the year 2010, what is the difference between the Aid flow (current US$) in Korea (Democratic) and Aid flow (current US$) in Papua New Guinea?
Give a very brief answer. -6.20e+05. In the year 2010, what is the difference between the Aid flow (current US$) of Lao PDR and Aid flow (current US$) of Papua New Guinea?
Provide a short and direct response. -9.70e+05. In the year 2011, what is the difference between the Aid flow (current US$) in Korea (Democratic) and Aid flow (current US$) in Malaysia?
Offer a terse response. -6.55e+06. In the year 2011, what is the difference between the Aid flow (current US$) of Lao PDR and Aid flow (current US$) of Malaysia?
Your response must be concise. -5.55e+06. In the year 2012, what is the difference between the Aid flow (current US$) in Korea (Democratic) and Aid flow (current US$) in Lao PDR?
Your answer should be very brief. -2.70e+05. In the year 2012, what is the difference between the Aid flow (current US$) in Korea (Democratic) and Aid flow (current US$) in Malaysia?
Your answer should be compact. -9.08e+06. In the year 2012, what is the difference between the Aid flow (current US$) of Korea (Democratic) and Aid flow (current US$) of Papua New Guinea?
Offer a terse response. -9.00e+05. In the year 2012, what is the difference between the Aid flow (current US$) in Lao PDR and Aid flow (current US$) in Malaysia?
Your response must be concise. -8.81e+06. In the year 2012, what is the difference between the Aid flow (current US$) of Lao PDR and Aid flow (current US$) of Papua New Guinea?
Provide a short and direct response. -6.30e+05. In the year 2012, what is the difference between the Aid flow (current US$) in Malaysia and Aid flow (current US$) in Papua New Guinea?
Offer a very short reply. 8.18e+06. In the year 2013, what is the difference between the Aid flow (current US$) of Korea (Democratic) and Aid flow (current US$) of Lao PDR?
Provide a short and direct response. 5.70e+05. In the year 2013, what is the difference between the Aid flow (current US$) in Korea (Democratic) and Aid flow (current US$) in Malaysia?
Provide a succinct answer. -4.08e+06. In the year 2013, what is the difference between the Aid flow (current US$) of Korea (Democratic) and Aid flow (current US$) of Papua New Guinea?
Make the answer very short. 4.50e+05. In the year 2013, what is the difference between the Aid flow (current US$) in Lao PDR and Aid flow (current US$) in Malaysia?
Your answer should be compact. -4.65e+06. In the year 2013, what is the difference between the Aid flow (current US$) in Malaysia and Aid flow (current US$) in Papua New Guinea?
Ensure brevity in your answer.  4.53e+06. What is the ratio of the Aid flow (current US$) in Korea (Democratic) in 1991 to that in 2007?
Offer a very short reply. 0.03. What is the ratio of the Aid flow (current US$) in Lao PDR in 1991 to that in 2007?
Your answer should be very brief. 0.04. What is the ratio of the Aid flow (current US$) in Papua New Guinea in 1991 to that in 2007?
Give a very brief answer. 3.1. What is the ratio of the Aid flow (current US$) in Korea (Democratic) in 1991 to that in 2008?
Your response must be concise. 0.15. What is the ratio of the Aid flow (current US$) in Lao PDR in 1991 to that in 2008?
Your answer should be very brief. 0.23. What is the ratio of the Aid flow (current US$) of Malaysia in 1991 to that in 2008?
Keep it short and to the point. 0.93. What is the ratio of the Aid flow (current US$) in Papua New Guinea in 1991 to that in 2008?
Your answer should be compact. 2.79. What is the ratio of the Aid flow (current US$) in Lao PDR in 1991 to that in 2009?
Your response must be concise. 0.23. What is the ratio of the Aid flow (current US$) in Malaysia in 1991 to that in 2009?
Provide a short and direct response. 4.22. What is the ratio of the Aid flow (current US$) in Papua New Guinea in 1991 to that in 2009?
Your answer should be very brief. 3.04. What is the ratio of the Aid flow (current US$) in Korea (Democratic) in 1991 to that in 2010?
Offer a very short reply. 0.1. What is the ratio of the Aid flow (current US$) in Lao PDR in 1991 to that in 2010?
Make the answer very short. 1.17. What is the ratio of the Aid flow (current US$) of Papua New Guinea in 1991 to that in 2010?
Your response must be concise. 2.89. What is the ratio of the Aid flow (current US$) of Korea (Democratic) in 1991 to that in 2011?
Ensure brevity in your answer.  0.07. What is the ratio of the Aid flow (current US$) in Lao PDR in 1991 to that in 2011?
Keep it short and to the point. 0.04. What is the ratio of the Aid flow (current US$) in Malaysia in 1991 to that in 2011?
Offer a terse response. 2.46. What is the ratio of the Aid flow (current US$) in Lao PDR in 1991 to that in 2012?
Give a very brief answer. 0.05. What is the ratio of the Aid flow (current US$) of Malaysia in 1991 to that in 2012?
Provide a succinct answer. 1.72. What is the ratio of the Aid flow (current US$) of Papua New Guinea in 1991 to that in 2012?
Your answer should be very brief. 1.42. What is the ratio of the Aid flow (current US$) of Korea (Democratic) in 1991 to that in 2013?
Provide a short and direct response. 0.02. What is the ratio of the Aid flow (current US$) of Lao PDR in 1991 to that in 2013?
Offer a terse response. 0.05. What is the ratio of the Aid flow (current US$) of Malaysia in 1991 to that in 2013?
Your answer should be very brief. 2.88. What is the ratio of the Aid flow (current US$) of Papua New Guinea in 1991 to that in 2013?
Your answer should be very brief. 1.86. What is the ratio of the Aid flow (current US$) of Korea (Democratic) in 2007 to that in 2008?
Offer a terse response. 4.33. What is the ratio of the Aid flow (current US$) in Lao PDR in 2007 to that in 2008?
Offer a very short reply. 5.39. What is the ratio of the Aid flow (current US$) in Papua New Guinea in 2007 to that in 2008?
Give a very brief answer. 0.9. What is the ratio of the Aid flow (current US$) of Korea (Democratic) in 2007 to that in 2009?
Give a very brief answer. 23.4. What is the ratio of the Aid flow (current US$) of Lao PDR in 2007 to that in 2009?
Give a very brief answer. 5.57. What is the ratio of the Aid flow (current US$) in Papua New Guinea in 2007 to that in 2009?
Provide a succinct answer. 0.98. What is the ratio of the Aid flow (current US$) in Korea (Democratic) in 2007 to that in 2010?
Offer a very short reply. 2.85. What is the ratio of the Aid flow (current US$) of Lao PDR in 2007 to that in 2010?
Provide a short and direct response. 27.83. What is the ratio of the Aid flow (current US$) in Papua New Guinea in 2007 to that in 2010?
Ensure brevity in your answer.  0.93. What is the ratio of the Aid flow (current US$) of Korea (Democratic) in 2007 to that in 2011?
Your response must be concise. 1.92. What is the ratio of the Aid flow (current US$) of Lao PDR in 2007 to that in 2011?
Offer a very short reply. 1.04. What is the ratio of the Aid flow (current US$) in Lao PDR in 2007 to that in 2012?
Your answer should be very brief. 1.14. What is the ratio of the Aid flow (current US$) of Papua New Guinea in 2007 to that in 2012?
Keep it short and to the point. 0.46. What is the ratio of the Aid flow (current US$) in Korea (Democratic) in 2007 to that in 2013?
Your response must be concise. 0.57. What is the ratio of the Aid flow (current US$) in Lao PDR in 2007 to that in 2013?
Make the answer very short. 1.13. What is the ratio of the Aid flow (current US$) of Papua New Guinea in 2007 to that in 2013?
Give a very brief answer. 0.6. What is the ratio of the Aid flow (current US$) in Lao PDR in 2008 to that in 2009?
Your answer should be compact. 1.03. What is the ratio of the Aid flow (current US$) in Malaysia in 2008 to that in 2009?
Your answer should be very brief. 4.53. What is the ratio of the Aid flow (current US$) of Papua New Guinea in 2008 to that in 2009?
Your answer should be compact. 1.09. What is the ratio of the Aid flow (current US$) of Korea (Democratic) in 2008 to that in 2010?
Provide a succinct answer. 0.66. What is the ratio of the Aid flow (current US$) of Lao PDR in 2008 to that in 2010?
Make the answer very short. 5.17. What is the ratio of the Aid flow (current US$) of Papua New Guinea in 2008 to that in 2010?
Ensure brevity in your answer.  1.04. What is the ratio of the Aid flow (current US$) of Korea (Democratic) in 2008 to that in 2011?
Your response must be concise. 0.44. What is the ratio of the Aid flow (current US$) in Lao PDR in 2008 to that in 2011?
Make the answer very short. 0.19. What is the ratio of the Aid flow (current US$) in Malaysia in 2008 to that in 2011?
Your answer should be compact. 2.64. What is the ratio of the Aid flow (current US$) of Korea (Democratic) in 2008 to that in 2012?
Make the answer very short. 0.23. What is the ratio of the Aid flow (current US$) in Lao PDR in 2008 to that in 2012?
Give a very brief answer. 0.21. What is the ratio of the Aid flow (current US$) in Malaysia in 2008 to that in 2012?
Your answer should be very brief. 1.84. What is the ratio of the Aid flow (current US$) of Papua New Guinea in 2008 to that in 2012?
Make the answer very short. 0.51. What is the ratio of the Aid flow (current US$) of Korea (Democratic) in 2008 to that in 2013?
Give a very brief answer. 0.13. What is the ratio of the Aid flow (current US$) in Lao PDR in 2008 to that in 2013?
Provide a succinct answer. 0.21. What is the ratio of the Aid flow (current US$) in Malaysia in 2008 to that in 2013?
Offer a terse response. 3.09. What is the ratio of the Aid flow (current US$) of Papua New Guinea in 2008 to that in 2013?
Offer a very short reply. 0.67. What is the ratio of the Aid flow (current US$) in Korea (Democratic) in 2009 to that in 2010?
Offer a very short reply. 0.12. What is the ratio of the Aid flow (current US$) in Papua New Guinea in 2009 to that in 2010?
Offer a terse response. 0.95. What is the ratio of the Aid flow (current US$) of Korea (Democratic) in 2009 to that in 2011?
Give a very brief answer. 0.08. What is the ratio of the Aid flow (current US$) of Lao PDR in 2009 to that in 2011?
Offer a terse response. 0.19. What is the ratio of the Aid flow (current US$) of Malaysia in 2009 to that in 2011?
Your answer should be compact. 0.58. What is the ratio of the Aid flow (current US$) in Korea (Democratic) in 2009 to that in 2012?
Your answer should be very brief. 0.04. What is the ratio of the Aid flow (current US$) in Lao PDR in 2009 to that in 2012?
Offer a terse response. 0.2. What is the ratio of the Aid flow (current US$) of Malaysia in 2009 to that in 2012?
Provide a short and direct response. 0.41. What is the ratio of the Aid flow (current US$) in Papua New Guinea in 2009 to that in 2012?
Your response must be concise. 0.47. What is the ratio of the Aid flow (current US$) in Korea (Democratic) in 2009 to that in 2013?
Offer a terse response. 0.02. What is the ratio of the Aid flow (current US$) of Lao PDR in 2009 to that in 2013?
Your answer should be very brief. 0.2. What is the ratio of the Aid flow (current US$) in Malaysia in 2009 to that in 2013?
Give a very brief answer. 0.68. What is the ratio of the Aid flow (current US$) in Papua New Guinea in 2009 to that in 2013?
Make the answer very short. 0.61. What is the ratio of the Aid flow (current US$) in Korea (Democratic) in 2010 to that in 2011?
Your response must be concise. 0.67. What is the ratio of the Aid flow (current US$) in Lao PDR in 2010 to that in 2011?
Provide a short and direct response. 0.04. What is the ratio of the Aid flow (current US$) in Korea (Democratic) in 2010 to that in 2012?
Ensure brevity in your answer.  0.34. What is the ratio of the Aid flow (current US$) in Lao PDR in 2010 to that in 2012?
Your answer should be compact. 0.04. What is the ratio of the Aid flow (current US$) of Papua New Guinea in 2010 to that in 2012?
Make the answer very short. 0.49. What is the ratio of the Aid flow (current US$) in Korea (Democratic) in 2010 to that in 2013?
Offer a terse response. 0.2. What is the ratio of the Aid flow (current US$) of Lao PDR in 2010 to that in 2013?
Offer a terse response. 0.04. What is the ratio of the Aid flow (current US$) of Papua New Guinea in 2010 to that in 2013?
Your response must be concise. 0.64. What is the ratio of the Aid flow (current US$) of Korea (Democratic) in 2011 to that in 2012?
Make the answer very short. 0.51. What is the ratio of the Aid flow (current US$) in Lao PDR in 2011 to that in 2012?
Your answer should be compact. 1.1. What is the ratio of the Aid flow (current US$) in Malaysia in 2011 to that in 2012?
Your answer should be compact. 0.7. What is the ratio of the Aid flow (current US$) of Korea (Democratic) in 2011 to that in 2013?
Your answer should be compact. 0.3. What is the ratio of the Aid flow (current US$) of Lao PDR in 2011 to that in 2013?
Offer a very short reply. 1.09. What is the ratio of the Aid flow (current US$) in Malaysia in 2011 to that in 2013?
Your response must be concise. 1.17. What is the ratio of the Aid flow (current US$) in Korea (Democratic) in 2012 to that in 2013?
Ensure brevity in your answer.  0.59. What is the ratio of the Aid flow (current US$) of Lao PDR in 2012 to that in 2013?
Give a very brief answer. 0.99. What is the ratio of the Aid flow (current US$) in Malaysia in 2012 to that in 2013?
Your answer should be compact. 1.68. What is the ratio of the Aid flow (current US$) in Papua New Guinea in 2012 to that in 2013?
Provide a succinct answer. 1.31. What is the difference between the highest and the second highest Aid flow (current US$) of Korea (Democratic)?
Provide a succinct answer. 8.50e+05. What is the difference between the highest and the second highest Aid flow (current US$) of Lao PDR?
Your answer should be very brief. 6.00e+04. What is the difference between the highest and the second highest Aid flow (current US$) in Malaysia?
Give a very brief answer. 1.28e+06. What is the difference between the highest and the second highest Aid flow (current US$) of Papua New Guinea?
Provide a short and direct response. 8.80e+05. What is the difference between the highest and the lowest Aid flow (current US$) in Korea (Democratic)?
Provide a succinct answer. 2.01e+06. What is the difference between the highest and the lowest Aid flow (current US$) of Lao PDR?
Provide a succinct answer. 1.61e+06. What is the difference between the highest and the lowest Aid flow (current US$) of Malaysia?
Make the answer very short. 1.89e+07. What is the difference between the highest and the lowest Aid flow (current US$) of Papua New Guinea?
Give a very brief answer. 2.98e+06. 